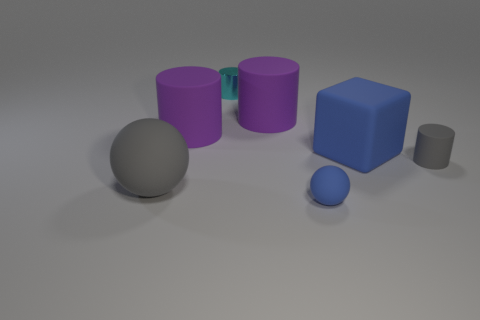There is a blue object in front of the gray rubber cylinder; what material is it?
Provide a short and direct response. Rubber. There is a tiny object that is to the right of the cyan cylinder and behind the large gray rubber thing; what shape is it?
Offer a terse response. Cylinder. What material is the small blue ball?
Give a very brief answer. Rubber. What number of cubes are cyan metallic things or small things?
Keep it short and to the point. 0. Is the material of the blue block the same as the cyan cylinder?
Ensure brevity in your answer.  No. The gray rubber object that is the same shape as the metal thing is what size?
Ensure brevity in your answer.  Small. The object that is both in front of the gray rubber cylinder and on the left side of the metal cylinder is made of what material?
Make the answer very short. Rubber. Are there an equal number of small metal things behind the shiny object and small green cylinders?
Your answer should be compact. Yes. What number of things are either things that are left of the cyan cylinder or small brown matte cylinders?
Ensure brevity in your answer.  2. Do the rubber sphere to the right of the large rubber sphere and the matte block have the same color?
Your answer should be compact. Yes. 